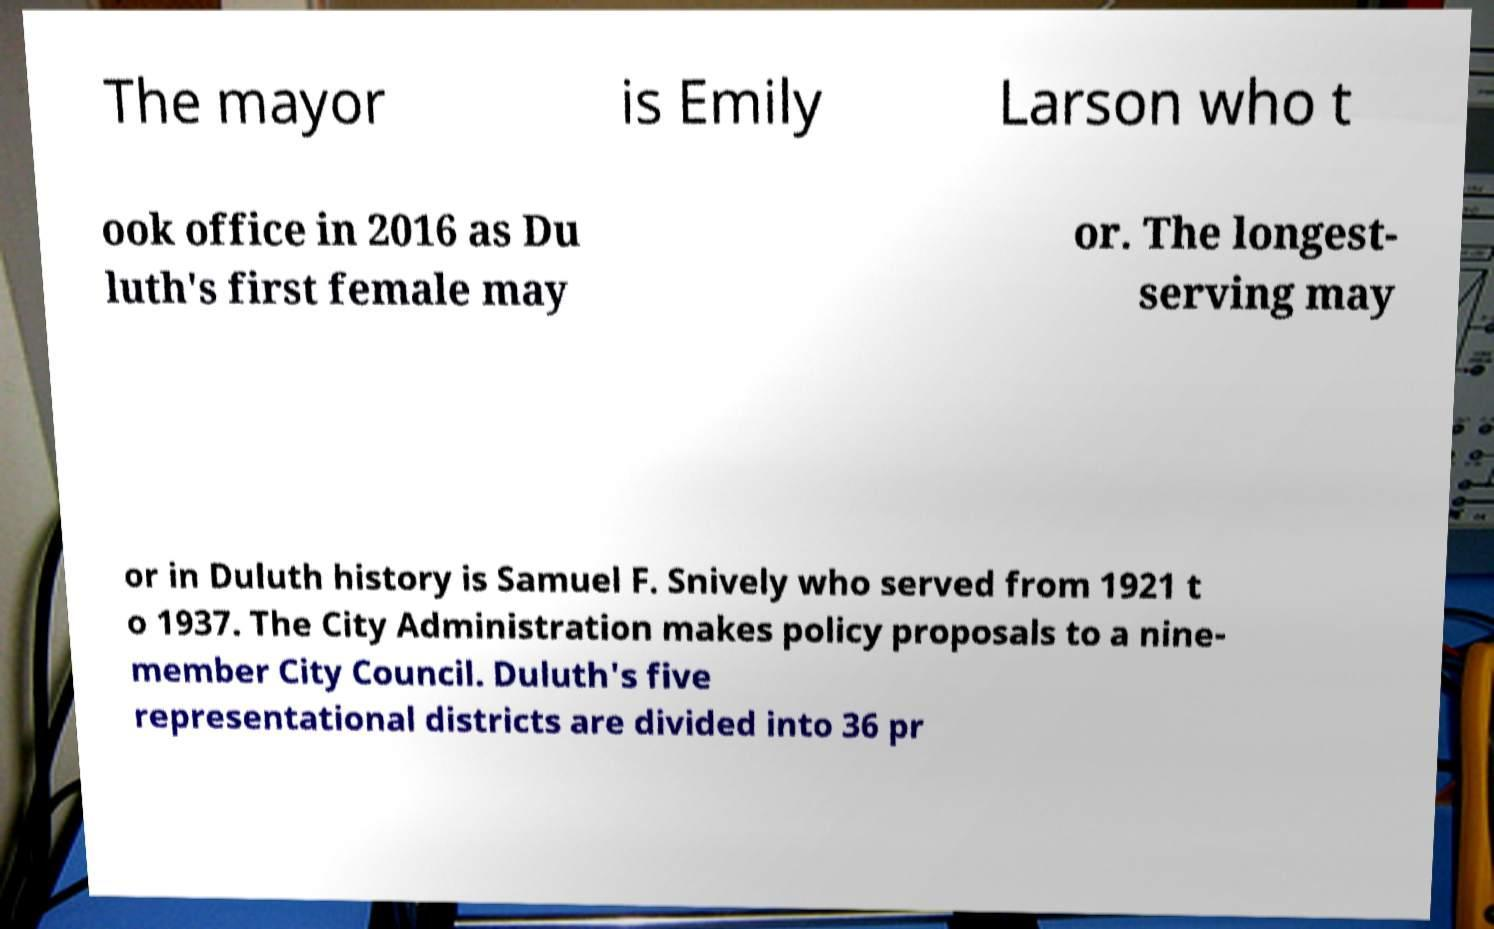Could you assist in decoding the text presented in this image and type it out clearly? The mayor is Emily Larson who t ook office in 2016 as Du luth's first female may or. The longest- serving may or in Duluth history is Samuel F. Snively who served from 1921 t o 1937. The City Administration makes policy proposals to a nine- member City Council. Duluth's five representational districts are divided into 36 pr 